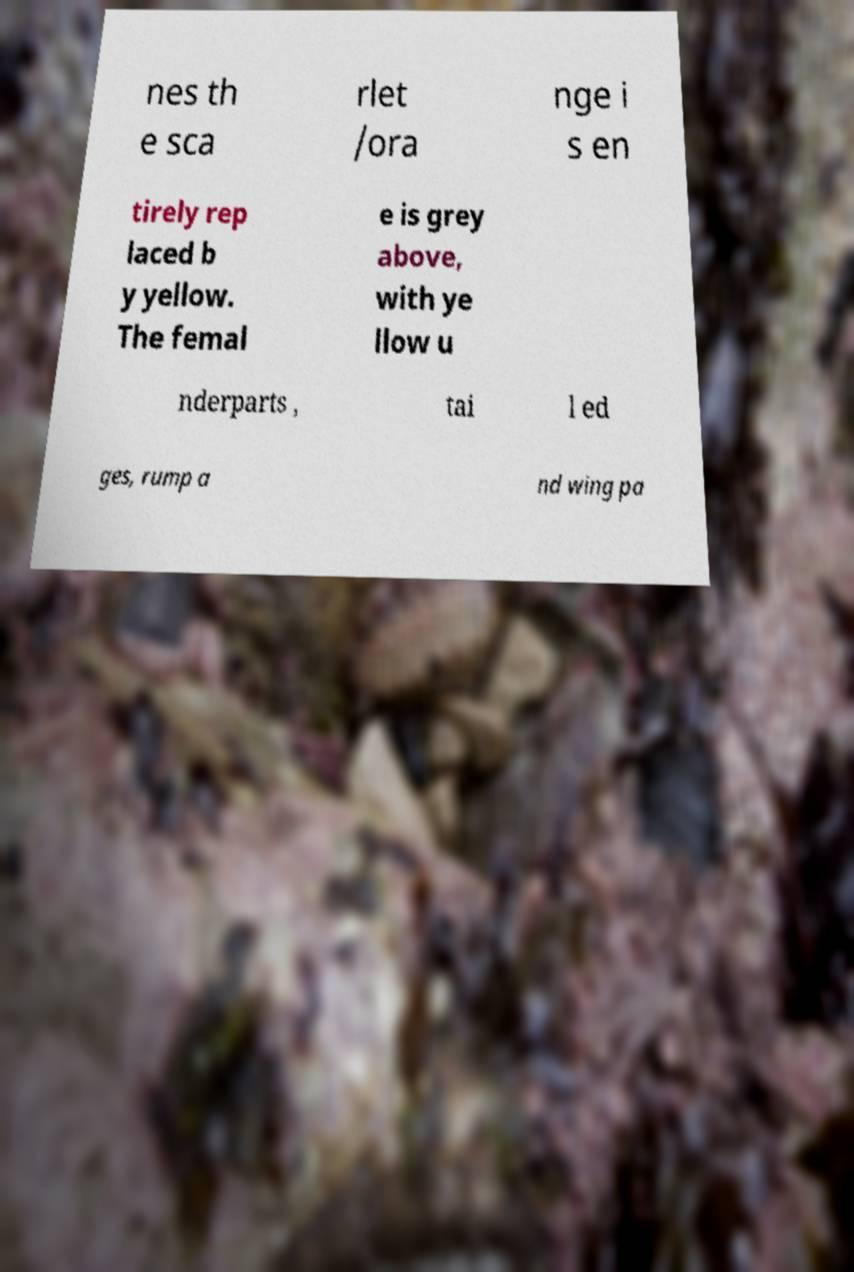Can you accurately transcribe the text from the provided image for me? nes th e sca rlet /ora nge i s en tirely rep laced b y yellow. The femal e is grey above, with ye llow u nderparts , tai l ed ges, rump a nd wing pa 